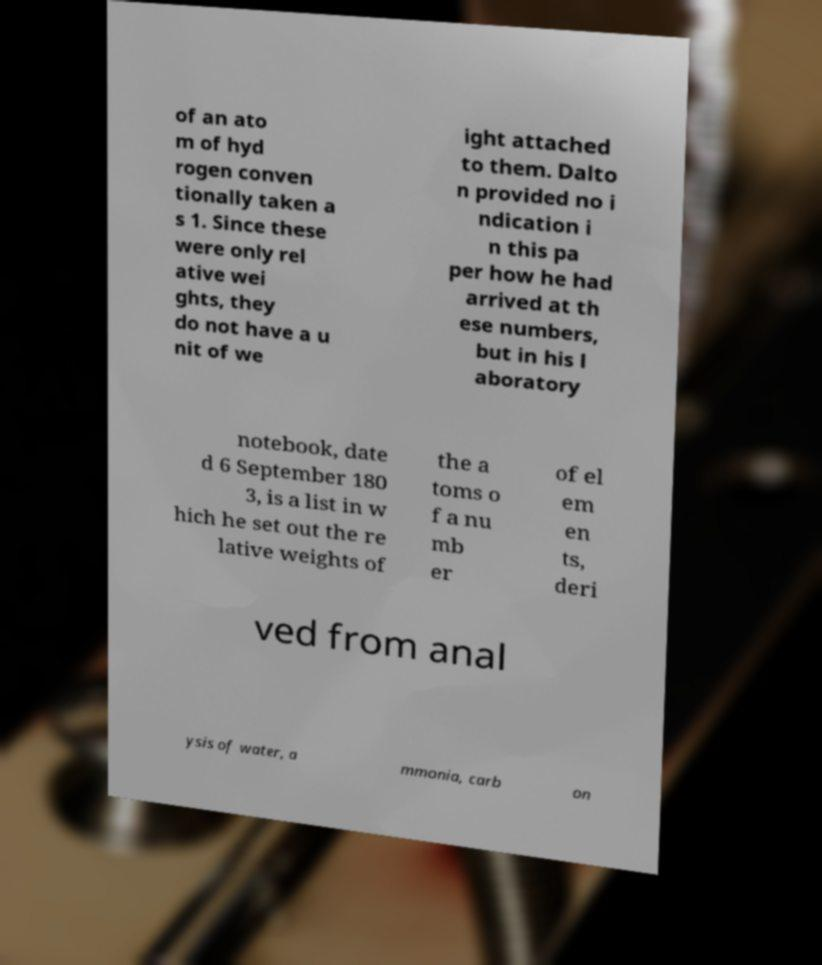For documentation purposes, I need the text within this image transcribed. Could you provide that? of an ato m of hyd rogen conven tionally taken a s 1. Since these were only rel ative wei ghts, they do not have a u nit of we ight attached to them. Dalto n provided no i ndication i n this pa per how he had arrived at th ese numbers, but in his l aboratory notebook, date d 6 September 180 3, is a list in w hich he set out the re lative weights of the a toms o f a nu mb er of el em en ts, deri ved from anal ysis of water, a mmonia, carb on 